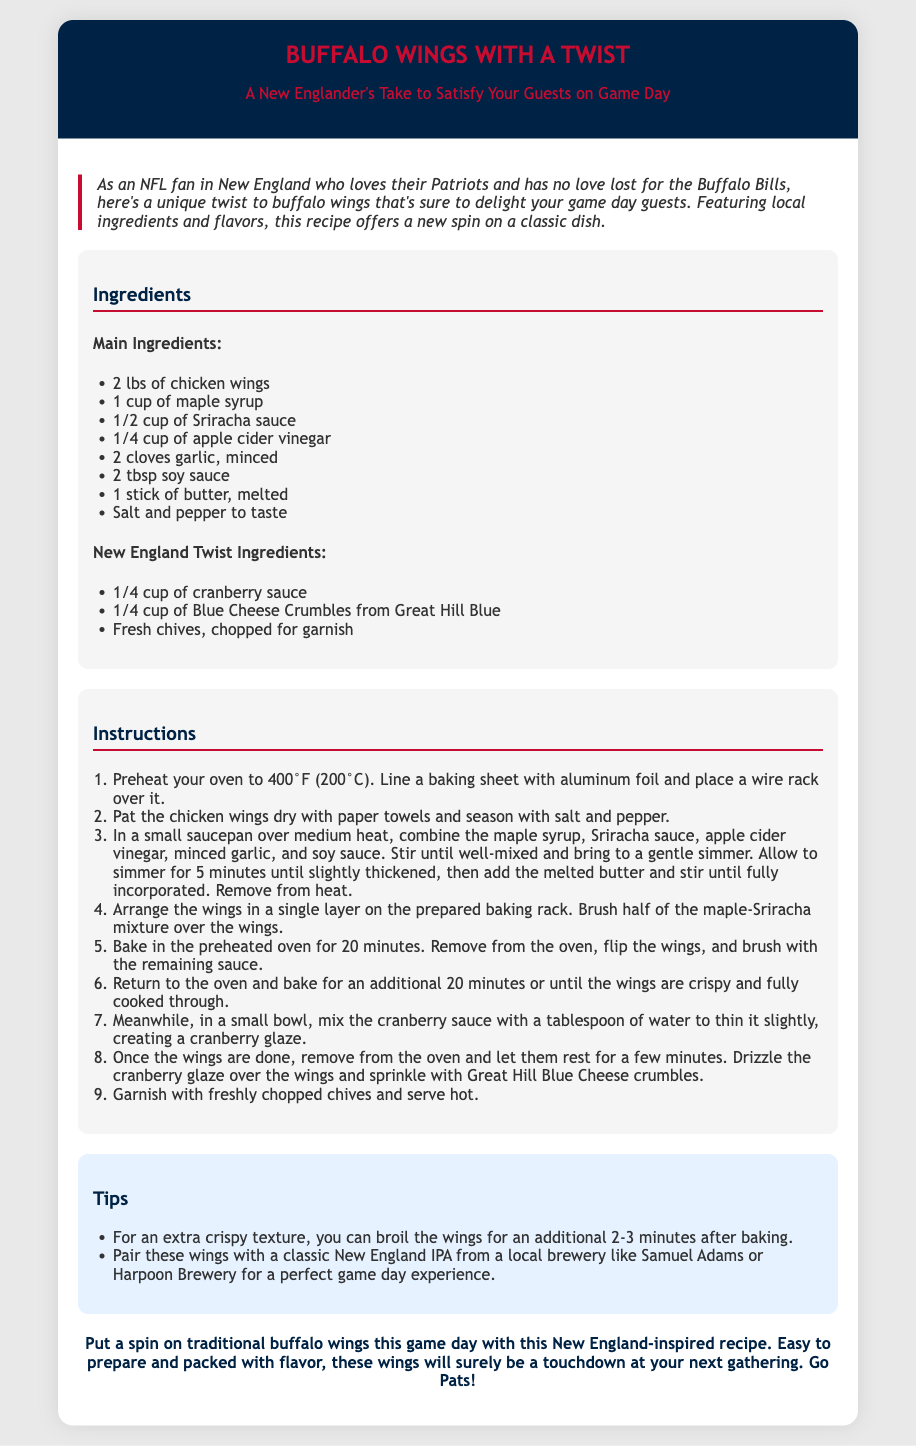What is the total weight of chicken wings used? The total weight of chicken wings mentioned in the ingredients list is 2 lbs.
Answer: 2 lbs What is a key ingredient added for the New England twist? The document mentions cranberry sauce as a specific ingredient that adds a local twist to the recipe.
Answer: cranberry sauce How long should the wings bake in total? The baking instructions indicate that the wings should bake for 40 minutes in total, divided into two 20-minute sessions.
Answer: 40 minutes Which brand of blue cheese is used in the recipe? The document specifies "Great Hill Blue" as the brand of blue cheese used in the recipe.
Answer: Great Hill Blue What temperature should the oven be preheated to? The instructions clearly state the oven should be preheated to 400°F (200°C).
Answer: 400°F What type of sauce is used to enhance the flavor? The recipe utilizes a mixture of maple syrup and Sriracha sauce for flavor enhancement.
Answer: maple syrup and Sriracha sauce What should you do for an extra crispy texture? The tips section suggests broiling the wings for an additional 2-3 minutes for extra crispiness.
Answer: broil for 2-3 minutes What local beverage is recommended to pair with the wings? The tips mention pairing the wings with a classic New England IPA from breweries like Samuel Adams or Harpoon Brewery.
Answer: New England IPA What is the color scheme of the recipe card? The recipe card features a background of light gray and blue with contrasting dark blue and red accents.
Answer: light gray and blue 